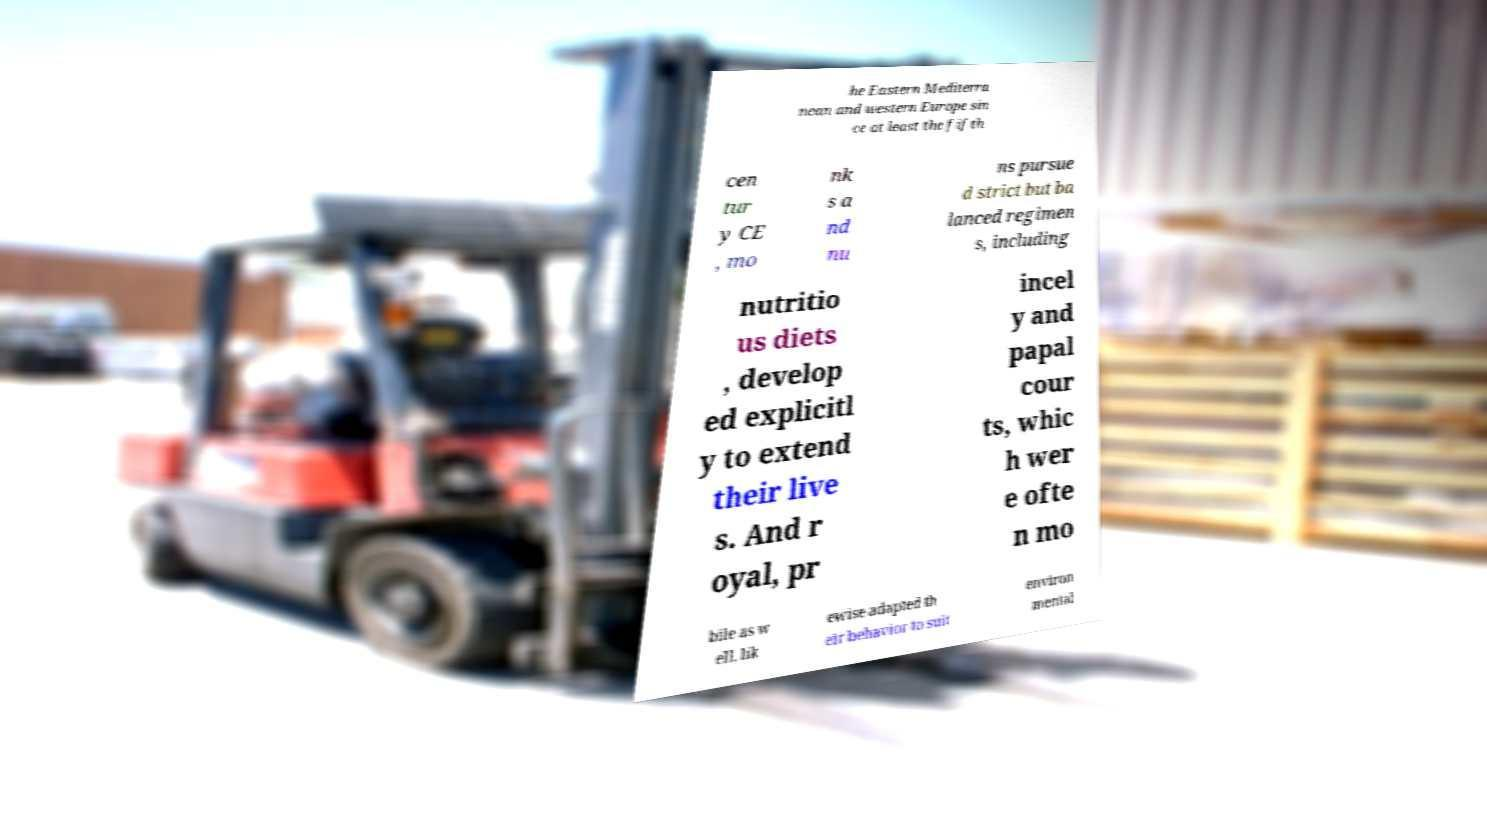Can you accurately transcribe the text from the provided image for me? he Eastern Mediterra nean and western Europe sin ce at least the fifth cen tur y CE , mo nk s a nd nu ns pursue d strict but ba lanced regimen s, including nutritio us diets , develop ed explicitl y to extend their live s. And r oyal, pr incel y and papal cour ts, whic h wer e ofte n mo bile as w ell, lik ewise adapted th eir behavior to suit environ mental 